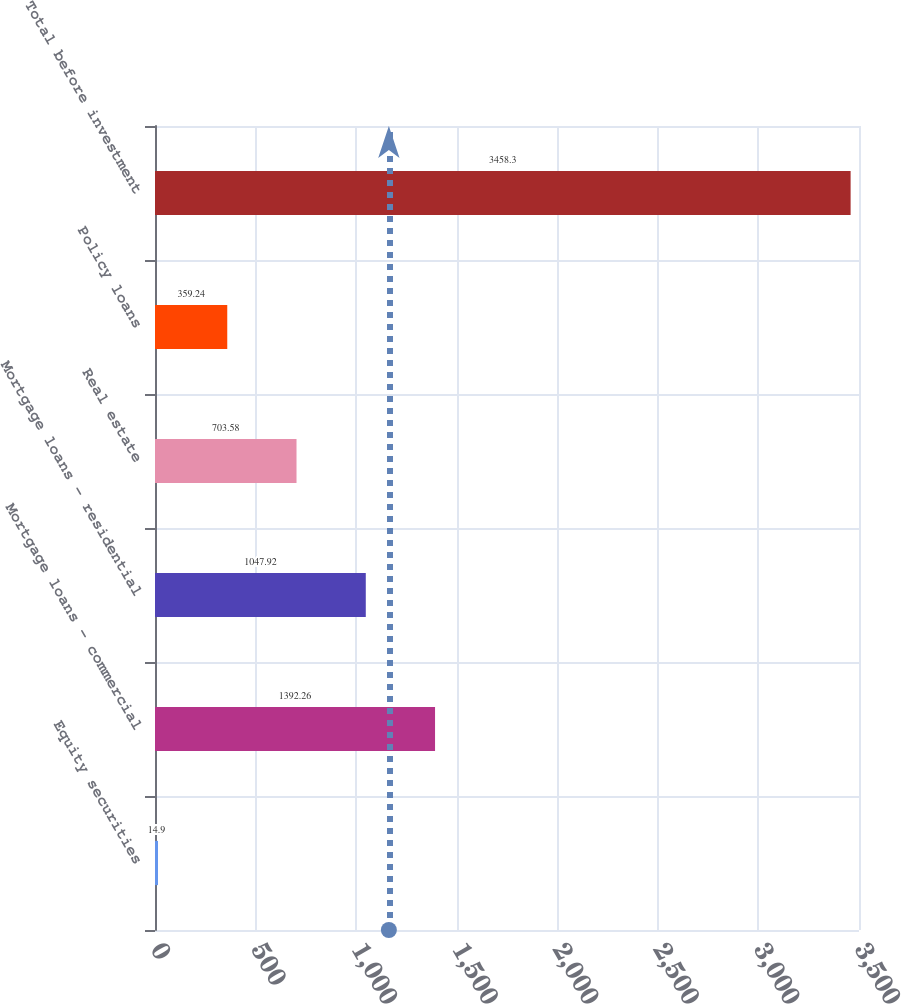<chart> <loc_0><loc_0><loc_500><loc_500><bar_chart><fcel>Equity securities<fcel>Mortgage loans - commercial<fcel>Mortgage loans - residential<fcel>Real estate<fcel>Policy loans<fcel>Total before investment<nl><fcel>14.9<fcel>1392.26<fcel>1047.92<fcel>703.58<fcel>359.24<fcel>3458.3<nl></chart> 